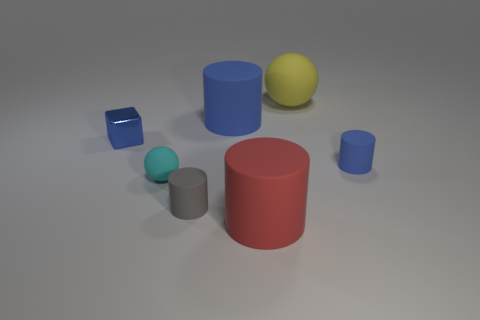Add 1 small blocks. How many objects exist? 8 Subtract all large red cylinders. How many cylinders are left? 3 Subtract 3 cylinders. How many cylinders are left? 1 Add 1 big objects. How many big objects exist? 4 Subtract all blue cylinders. How many cylinders are left? 2 Subtract 0 brown balls. How many objects are left? 7 Subtract all blocks. How many objects are left? 6 Subtract all cyan blocks. Subtract all blue cylinders. How many blocks are left? 1 Subtract all yellow cubes. How many yellow balls are left? 1 Subtract all small brown matte cylinders. Subtract all large yellow spheres. How many objects are left? 6 